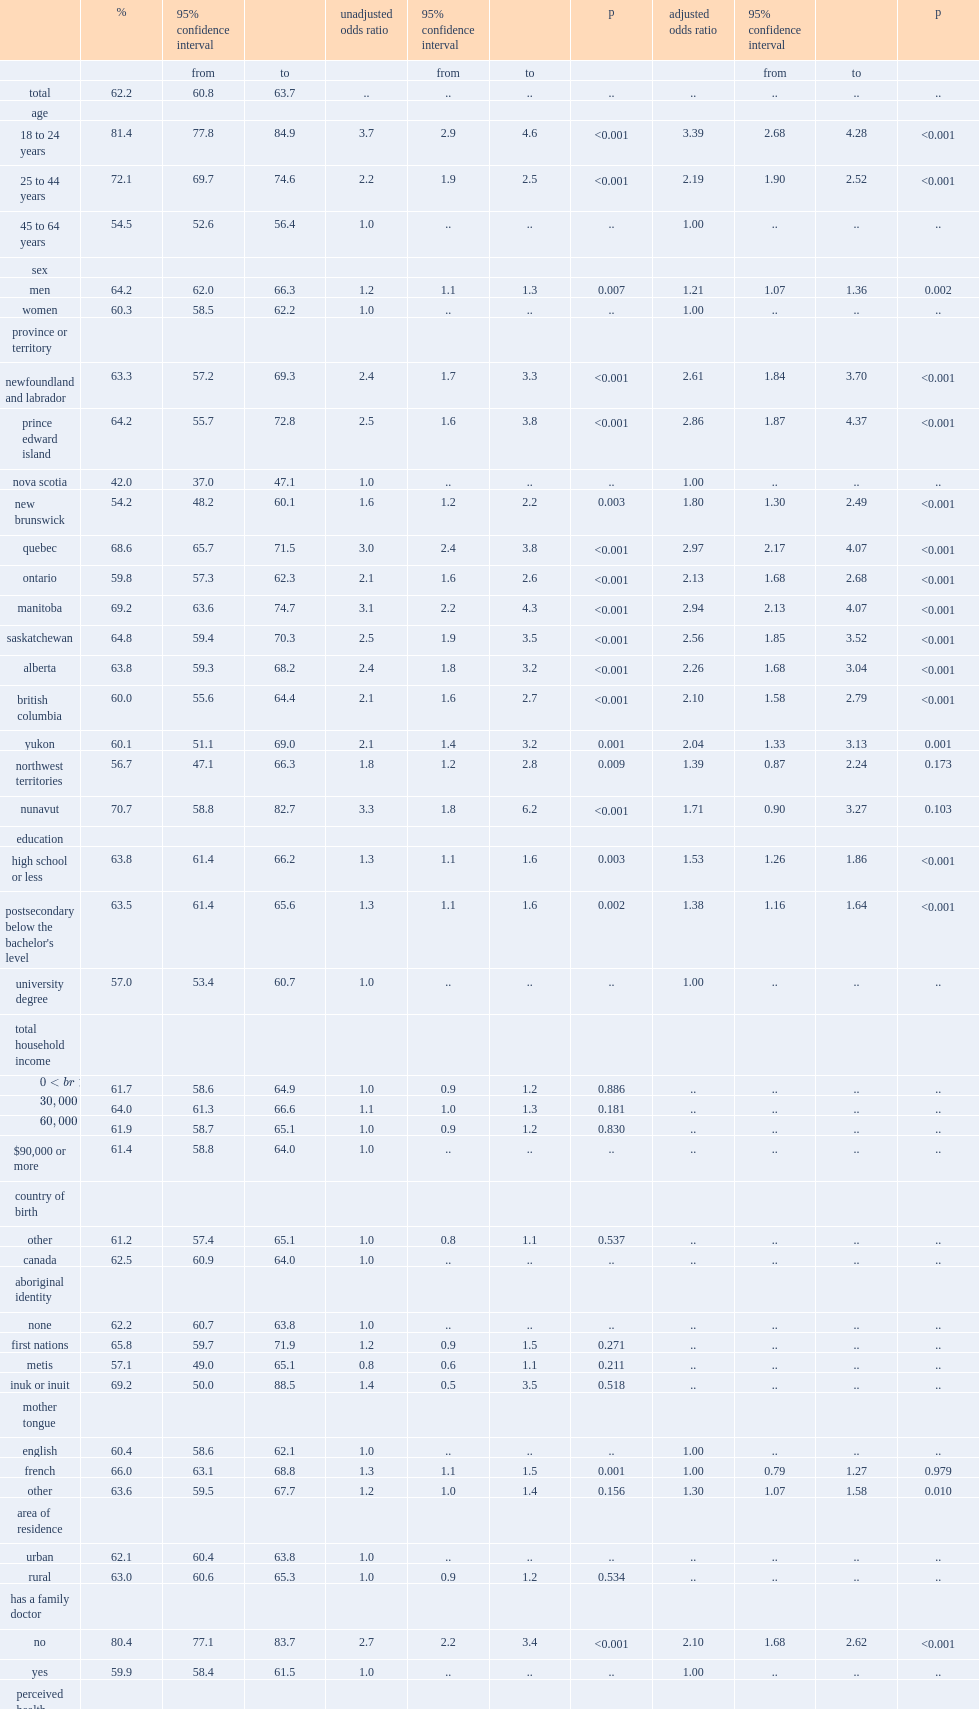What is the proportion of non-vaccinated persons among adults aged 18 to 64 years with a cmc? 62.2. 